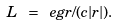Convert formula to latex. <formula><loc_0><loc_0><loc_500><loc_500>L \ = \ e g r / ( c | r | ) .</formula> 